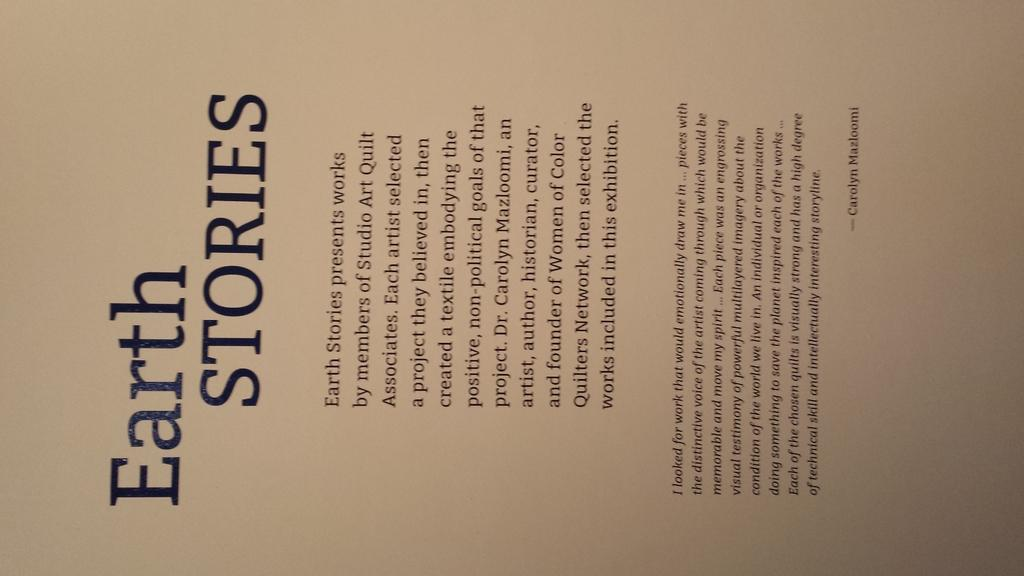Provide a one-sentence caption for the provided image. Page of text book called Earth Stories by members of Studio Art Quilt Associates. 